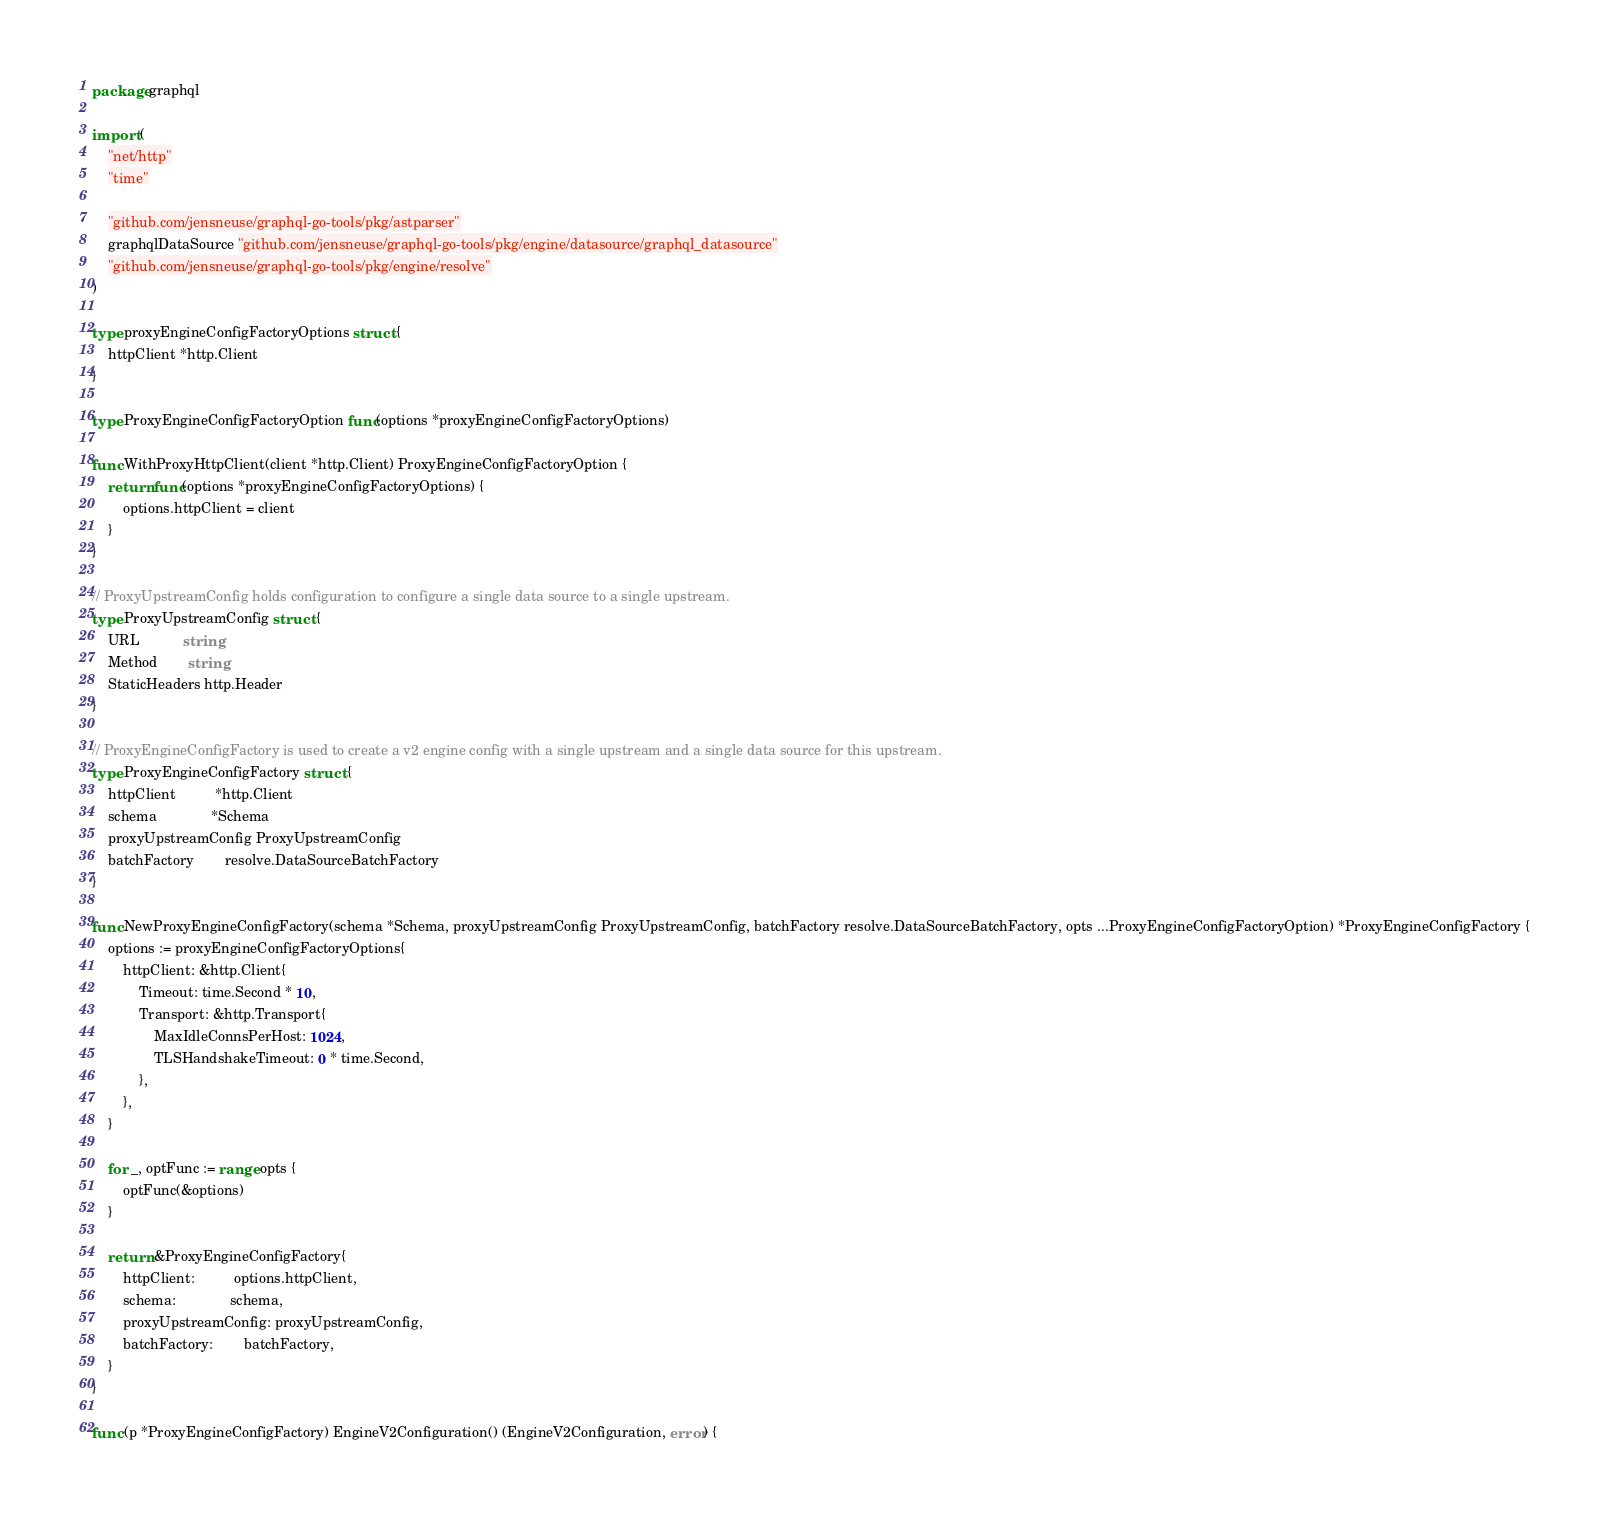Convert code to text. <code><loc_0><loc_0><loc_500><loc_500><_Go_>package graphql

import (
	"net/http"
	"time"

	"github.com/jensneuse/graphql-go-tools/pkg/astparser"
	graphqlDataSource "github.com/jensneuse/graphql-go-tools/pkg/engine/datasource/graphql_datasource"
	"github.com/jensneuse/graphql-go-tools/pkg/engine/resolve"
)

type proxyEngineConfigFactoryOptions struct {
	httpClient *http.Client
}

type ProxyEngineConfigFactoryOption func(options *proxyEngineConfigFactoryOptions)

func WithProxyHttpClient(client *http.Client) ProxyEngineConfigFactoryOption {
	return func(options *proxyEngineConfigFactoryOptions) {
		options.httpClient = client
	}
}

// ProxyUpstreamConfig holds configuration to configure a single data source to a single upstream.
type ProxyUpstreamConfig struct {
	URL           string
	Method        string
	StaticHeaders http.Header
}

// ProxyEngineConfigFactory is used to create a v2 engine config with a single upstream and a single data source for this upstream.
type ProxyEngineConfigFactory struct {
	httpClient          *http.Client
	schema              *Schema
	proxyUpstreamConfig ProxyUpstreamConfig
	batchFactory        resolve.DataSourceBatchFactory
}

func NewProxyEngineConfigFactory(schema *Schema, proxyUpstreamConfig ProxyUpstreamConfig, batchFactory resolve.DataSourceBatchFactory, opts ...ProxyEngineConfigFactoryOption) *ProxyEngineConfigFactory {
	options := proxyEngineConfigFactoryOptions{
		httpClient: &http.Client{
			Timeout: time.Second * 10,
			Transport: &http.Transport{
				MaxIdleConnsPerHost: 1024,
				TLSHandshakeTimeout: 0 * time.Second,
			},
		},
	}

	for _, optFunc := range opts {
		optFunc(&options)
	}

	return &ProxyEngineConfigFactory{
		httpClient:          options.httpClient,
		schema:              schema,
		proxyUpstreamConfig: proxyUpstreamConfig,
		batchFactory:        batchFactory,
	}
}

func (p *ProxyEngineConfigFactory) EngineV2Configuration() (EngineV2Configuration, error) {</code> 